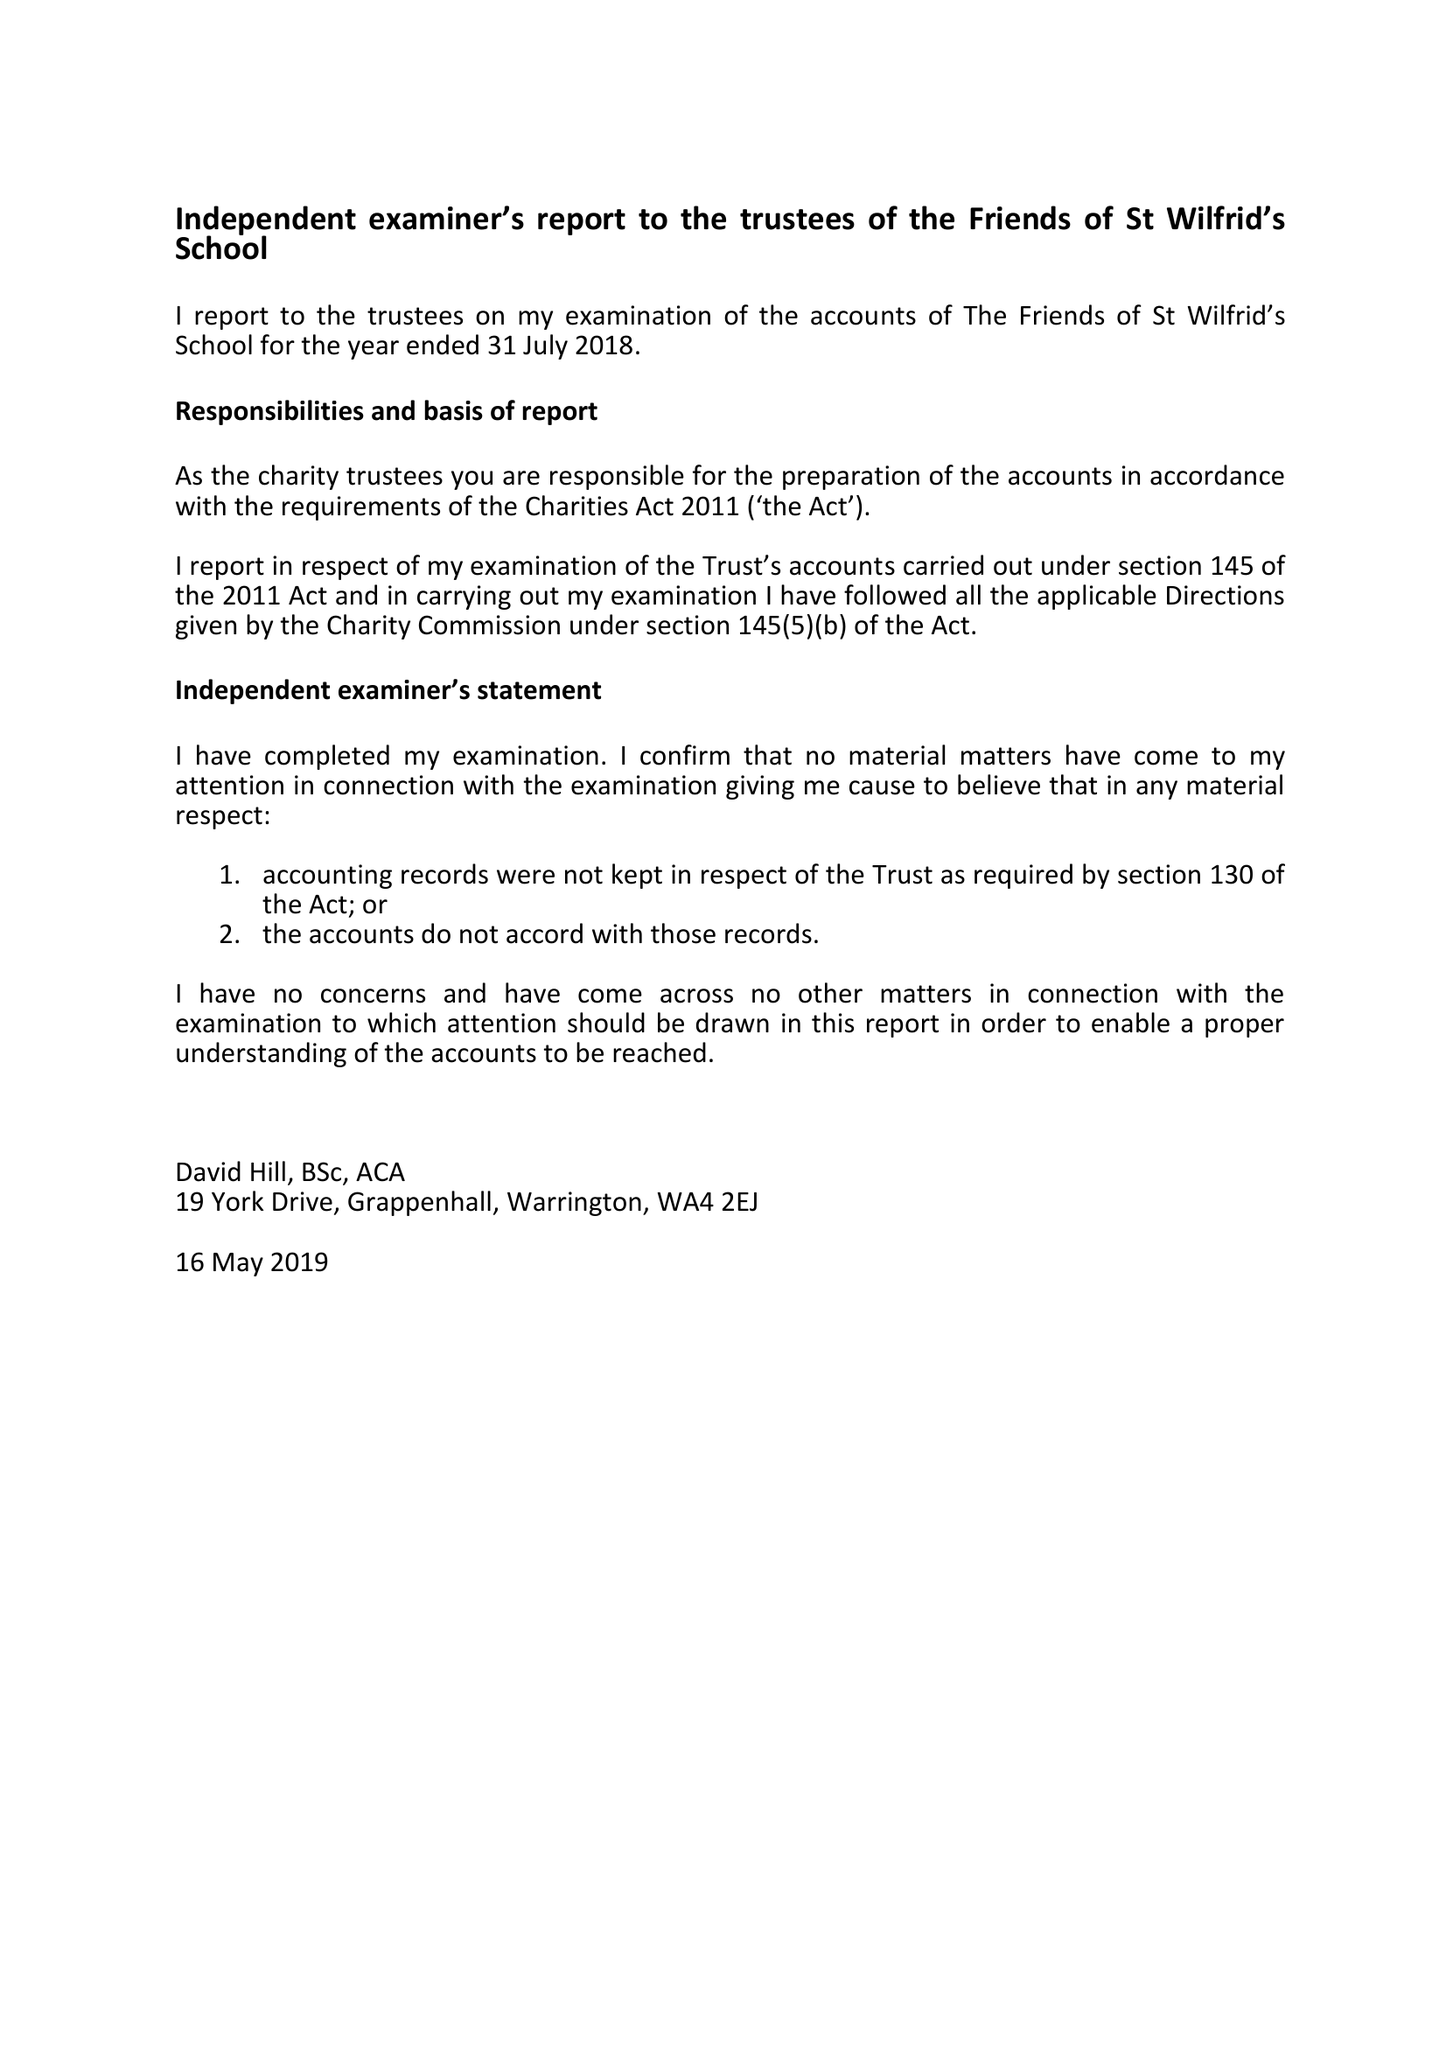What is the value for the report_date?
Answer the question using a single word or phrase. 2018-07-31 